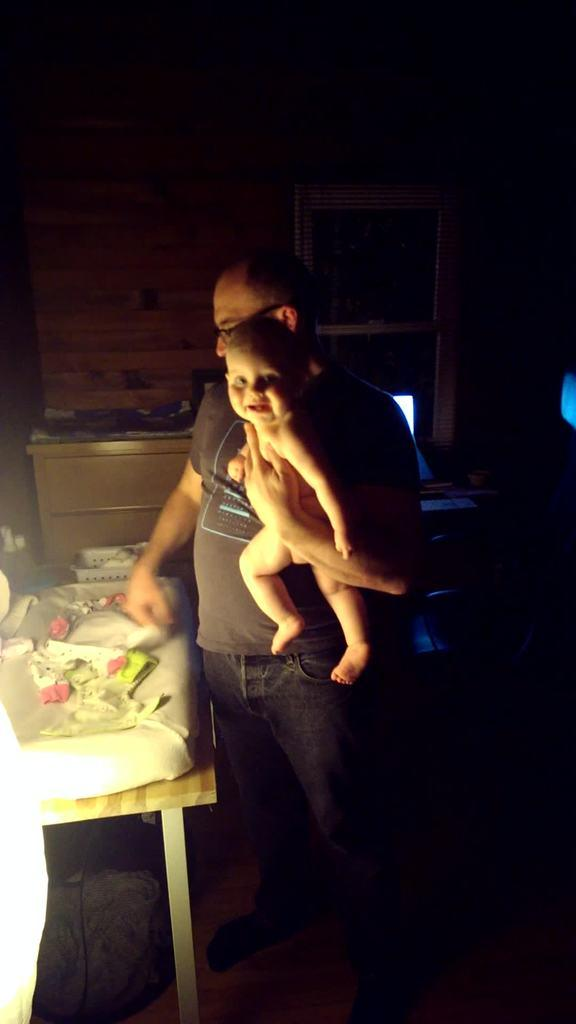What is the person in the image doing? The person is holding a child in the image. What can be seen in the background of the image? There is a wall visible in the image. What is located near the person and child? There is a table in the image. What is on the table? There are objects on the table in the image. What is beside the table? There are objects beside the table in the image. What type of ray is visible in the image? There is no ray present in the image. What statement is being made by the person holding the child? The image does not provide any information about a statement being made by the person holding the child. 